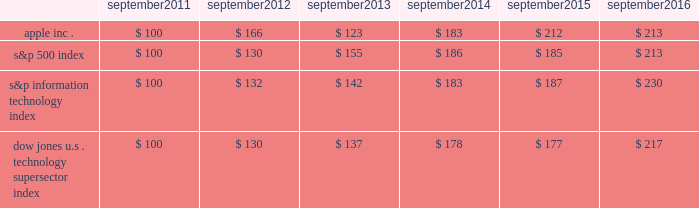Apple inc .
| 2016 form 10-k | 20 company stock performance the following graph shows a comparison of cumulative total shareholder return , calculated on a dividend reinvested basis , for the company , the s&p 500 index , the s&p information technology index and the dow jones u.s .
Technology supersector index for the five years ended september 24 , 2016 .
The graph assumes $ 100 was invested in each of the company 2019s common stock , the s&p 500 index , the s&p information technology index and the dow jones u.s .
Technology supersector index as of the market close on september 23 , 2011 .
Note that historic stock price performance is not necessarily indicative of future stock price performance .
* $ 100 invested on 9/23/11 in stock or index , including reinvestment of dividends .
Data points are the last day of each fiscal year for the company 2019s common stock and september 30th for indexes .
Copyright a9 2016 s&p , a division of mcgraw hill financial .
All rights reserved .
Copyright a9 2016 dow jones & co .
All rights reserved .
September september september september september september .

What was the cumulative change in apple inc . stock between 2016 and 2011? 
Computations: (213 - 100)
Answer: 113.0. 